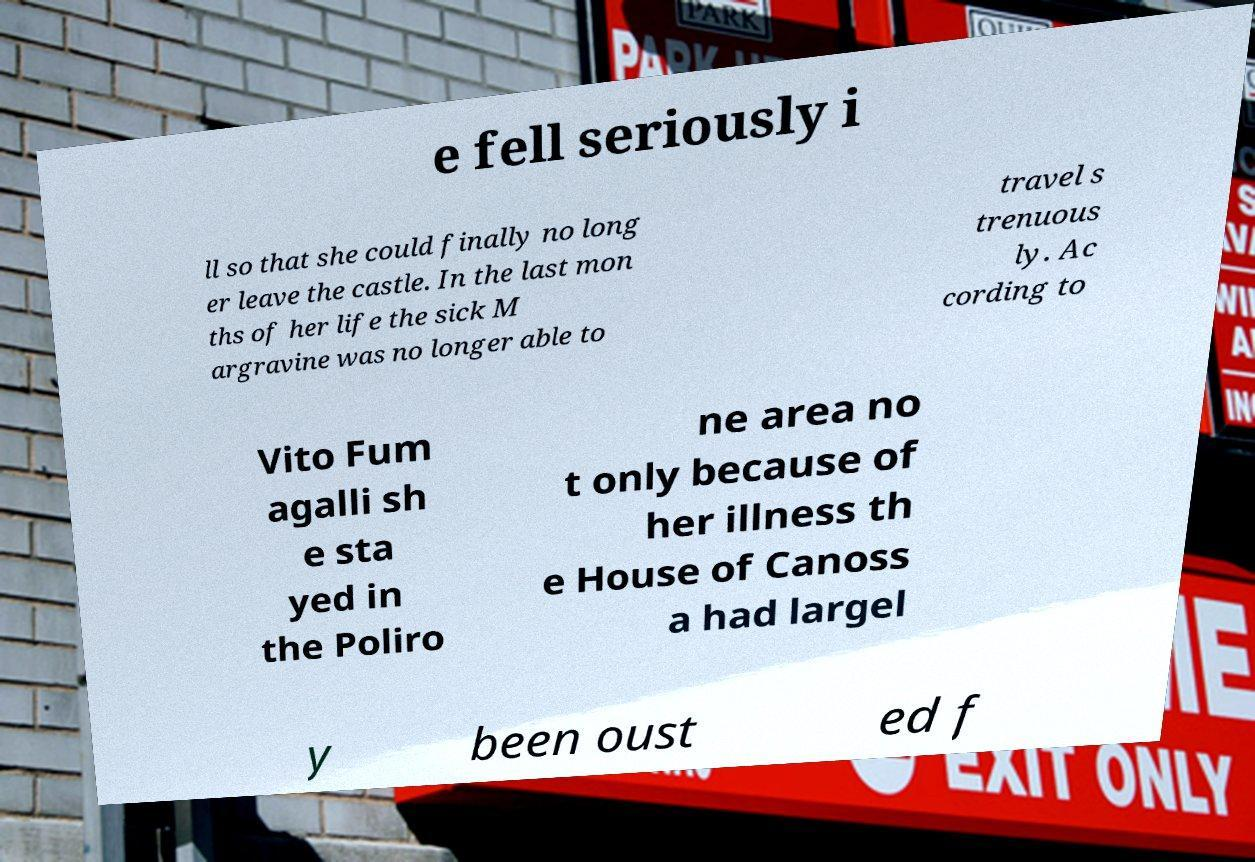Could you extract and type out the text from this image? e fell seriously i ll so that she could finally no long er leave the castle. In the last mon ths of her life the sick M argravine was no longer able to travel s trenuous ly. Ac cording to Vito Fum agalli sh e sta yed in the Poliro ne area no t only because of her illness th e House of Canoss a had largel y been oust ed f 